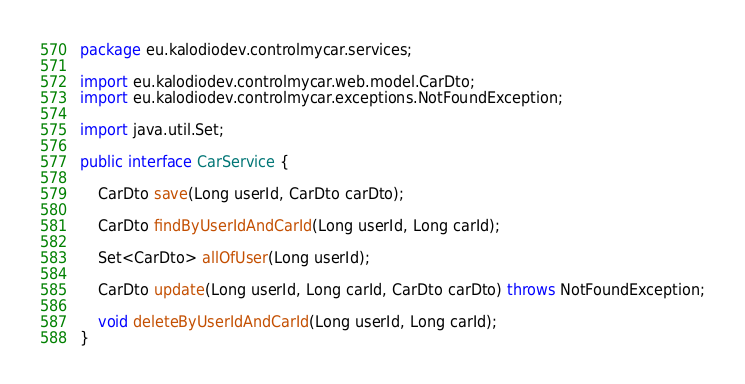<code> <loc_0><loc_0><loc_500><loc_500><_Java_>package eu.kalodiodev.controlmycar.services;

import eu.kalodiodev.controlmycar.web.model.CarDto;
import eu.kalodiodev.controlmycar.exceptions.NotFoundException;

import java.util.Set;

public interface CarService {

    CarDto save(Long userId, CarDto carDto);

    CarDto findByUserIdAndCarId(Long userId, Long carId);

    Set<CarDto> allOfUser(Long userId);

    CarDto update(Long userId, Long carId, CarDto carDto) throws NotFoundException;

    void deleteByUserIdAndCarId(Long userId, Long carId);
}
</code> 